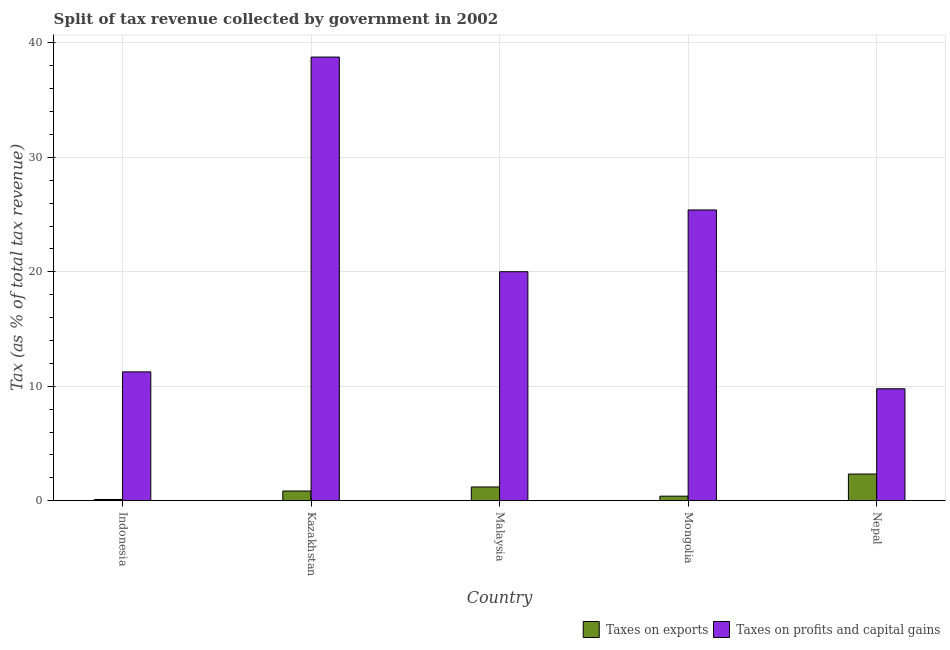Are the number of bars on each tick of the X-axis equal?
Your answer should be compact. Yes. How many bars are there on the 3rd tick from the right?
Your answer should be very brief. 2. What is the percentage of revenue obtained from taxes on exports in Nepal?
Provide a short and direct response. 2.33. Across all countries, what is the maximum percentage of revenue obtained from taxes on profits and capital gains?
Your answer should be very brief. 38.77. Across all countries, what is the minimum percentage of revenue obtained from taxes on profits and capital gains?
Offer a very short reply. 9.78. In which country was the percentage of revenue obtained from taxes on exports maximum?
Your answer should be compact. Nepal. In which country was the percentage of revenue obtained from taxes on profits and capital gains minimum?
Ensure brevity in your answer.  Nepal. What is the total percentage of revenue obtained from taxes on exports in the graph?
Your response must be concise. 4.89. What is the difference between the percentage of revenue obtained from taxes on exports in Indonesia and that in Malaysia?
Your answer should be very brief. -1.09. What is the difference between the percentage of revenue obtained from taxes on exports in Nepal and the percentage of revenue obtained from taxes on profits and capital gains in Mongolia?
Give a very brief answer. -23.07. What is the average percentage of revenue obtained from taxes on profits and capital gains per country?
Ensure brevity in your answer.  21.04. What is the difference between the percentage of revenue obtained from taxes on exports and percentage of revenue obtained from taxes on profits and capital gains in Malaysia?
Your answer should be very brief. -18.81. In how many countries, is the percentage of revenue obtained from taxes on profits and capital gains greater than 8 %?
Offer a terse response. 5. What is the ratio of the percentage of revenue obtained from taxes on exports in Malaysia to that in Mongolia?
Your answer should be compact. 3.02. What is the difference between the highest and the second highest percentage of revenue obtained from taxes on exports?
Your response must be concise. 1.13. What is the difference between the highest and the lowest percentage of revenue obtained from taxes on profits and capital gains?
Your response must be concise. 28.98. What does the 1st bar from the left in Indonesia represents?
Your answer should be compact. Taxes on exports. What does the 1st bar from the right in Kazakhstan represents?
Provide a succinct answer. Taxes on profits and capital gains. Are all the bars in the graph horizontal?
Your answer should be compact. No. How many countries are there in the graph?
Provide a succinct answer. 5. What is the difference between two consecutive major ticks on the Y-axis?
Give a very brief answer. 10. Does the graph contain grids?
Offer a terse response. Yes. Where does the legend appear in the graph?
Give a very brief answer. Bottom right. How are the legend labels stacked?
Make the answer very short. Horizontal. What is the title of the graph?
Provide a succinct answer. Split of tax revenue collected by government in 2002. Does "Researchers" appear as one of the legend labels in the graph?
Ensure brevity in your answer.  No. What is the label or title of the X-axis?
Your answer should be very brief. Country. What is the label or title of the Y-axis?
Offer a terse response. Tax (as % of total tax revenue). What is the Tax (as % of total tax revenue) of Taxes on exports in Indonesia?
Offer a terse response. 0.11. What is the Tax (as % of total tax revenue) of Taxes on profits and capital gains in Indonesia?
Your response must be concise. 11.26. What is the Tax (as % of total tax revenue) in Taxes on exports in Kazakhstan?
Offer a terse response. 0.85. What is the Tax (as % of total tax revenue) in Taxes on profits and capital gains in Kazakhstan?
Offer a very short reply. 38.77. What is the Tax (as % of total tax revenue) of Taxes on exports in Malaysia?
Make the answer very short. 1.2. What is the Tax (as % of total tax revenue) of Taxes on profits and capital gains in Malaysia?
Offer a very short reply. 20.01. What is the Tax (as % of total tax revenue) in Taxes on exports in Mongolia?
Offer a very short reply. 0.4. What is the Tax (as % of total tax revenue) of Taxes on profits and capital gains in Mongolia?
Offer a very short reply. 25.41. What is the Tax (as % of total tax revenue) of Taxes on exports in Nepal?
Keep it short and to the point. 2.33. What is the Tax (as % of total tax revenue) in Taxes on profits and capital gains in Nepal?
Offer a very short reply. 9.78. Across all countries, what is the maximum Tax (as % of total tax revenue) in Taxes on exports?
Provide a succinct answer. 2.33. Across all countries, what is the maximum Tax (as % of total tax revenue) in Taxes on profits and capital gains?
Your response must be concise. 38.77. Across all countries, what is the minimum Tax (as % of total tax revenue) of Taxes on exports?
Give a very brief answer. 0.11. Across all countries, what is the minimum Tax (as % of total tax revenue) in Taxes on profits and capital gains?
Your response must be concise. 9.78. What is the total Tax (as % of total tax revenue) in Taxes on exports in the graph?
Offer a terse response. 4.89. What is the total Tax (as % of total tax revenue) of Taxes on profits and capital gains in the graph?
Keep it short and to the point. 105.22. What is the difference between the Tax (as % of total tax revenue) in Taxes on exports in Indonesia and that in Kazakhstan?
Offer a very short reply. -0.74. What is the difference between the Tax (as % of total tax revenue) in Taxes on profits and capital gains in Indonesia and that in Kazakhstan?
Offer a very short reply. -27.51. What is the difference between the Tax (as % of total tax revenue) of Taxes on exports in Indonesia and that in Malaysia?
Your answer should be very brief. -1.09. What is the difference between the Tax (as % of total tax revenue) of Taxes on profits and capital gains in Indonesia and that in Malaysia?
Give a very brief answer. -8.75. What is the difference between the Tax (as % of total tax revenue) in Taxes on exports in Indonesia and that in Mongolia?
Give a very brief answer. -0.29. What is the difference between the Tax (as % of total tax revenue) of Taxes on profits and capital gains in Indonesia and that in Mongolia?
Keep it short and to the point. -14.15. What is the difference between the Tax (as % of total tax revenue) of Taxes on exports in Indonesia and that in Nepal?
Give a very brief answer. -2.22. What is the difference between the Tax (as % of total tax revenue) in Taxes on profits and capital gains in Indonesia and that in Nepal?
Provide a succinct answer. 1.48. What is the difference between the Tax (as % of total tax revenue) in Taxes on exports in Kazakhstan and that in Malaysia?
Give a very brief answer. -0.35. What is the difference between the Tax (as % of total tax revenue) in Taxes on profits and capital gains in Kazakhstan and that in Malaysia?
Ensure brevity in your answer.  18.76. What is the difference between the Tax (as % of total tax revenue) in Taxes on exports in Kazakhstan and that in Mongolia?
Offer a terse response. 0.45. What is the difference between the Tax (as % of total tax revenue) of Taxes on profits and capital gains in Kazakhstan and that in Mongolia?
Your response must be concise. 13.36. What is the difference between the Tax (as % of total tax revenue) of Taxes on exports in Kazakhstan and that in Nepal?
Your answer should be very brief. -1.48. What is the difference between the Tax (as % of total tax revenue) in Taxes on profits and capital gains in Kazakhstan and that in Nepal?
Your answer should be compact. 28.98. What is the difference between the Tax (as % of total tax revenue) of Taxes on exports in Malaysia and that in Mongolia?
Make the answer very short. 0.8. What is the difference between the Tax (as % of total tax revenue) in Taxes on profits and capital gains in Malaysia and that in Mongolia?
Offer a terse response. -5.4. What is the difference between the Tax (as % of total tax revenue) in Taxes on exports in Malaysia and that in Nepal?
Keep it short and to the point. -1.13. What is the difference between the Tax (as % of total tax revenue) of Taxes on profits and capital gains in Malaysia and that in Nepal?
Ensure brevity in your answer.  10.23. What is the difference between the Tax (as % of total tax revenue) of Taxes on exports in Mongolia and that in Nepal?
Provide a succinct answer. -1.93. What is the difference between the Tax (as % of total tax revenue) of Taxes on profits and capital gains in Mongolia and that in Nepal?
Keep it short and to the point. 15.62. What is the difference between the Tax (as % of total tax revenue) in Taxes on exports in Indonesia and the Tax (as % of total tax revenue) in Taxes on profits and capital gains in Kazakhstan?
Offer a very short reply. -38.66. What is the difference between the Tax (as % of total tax revenue) of Taxes on exports in Indonesia and the Tax (as % of total tax revenue) of Taxes on profits and capital gains in Malaysia?
Your response must be concise. -19.9. What is the difference between the Tax (as % of total tax revenue) in Taxes on exports in Indonesia and the Tax (as % of total tax revenue) in Taxes on profits and capital gains in Mongolia?
Offer a very short reply. -25.3. What is the difference between the Tax (as % of total tax revenue) in Taxes on exports in Indonesia and the Tax (as % of total tax revenue) in Taxes on profits and capital gains in Nepal?
Provide a succinct answer. -9.68. What is the difference between the Tax (as % of total tax revenue) of Taxes on exports in Kazakhstan and the Tax (as % of total tax revenue) of Taxes on profits and capital gains in Malaysia?
Your answer should be very brief. -19.16. What is the difference between the Tax (as % of total tax revenue) of Taxes on exports in Kazakhstan and the Tax (as % of total tax revenue) of Taxes on profits and capital gains in Mongolia?
Give a very brief answer. -24.56. What is the difference between the Tax (as % of total tax revenue) in Taxes on exports in Kazakhstan and the Tax (as % of total tax revenue) in Taxes on profits and capital gains in Nepal?
Offer a very short reply. -8.94. What is the difference between the Tax (as % of total tax revenue) in Taxes on exports in Malaysia and the Tax (as % of total tax revenue) in Taxes on profits and capital gains in Mongolia?
Ensure brevity in your answer.  -24.21. What is the difference between the Tax (as % of total tax revenue) in Taxes on exports in Malaysia and the Tax (as % of total tax revenue) in Taxes on profits and capital gains in Nepal?
Ensure brevity in your answer.  -8.58. What is the difference between the Tax (as % of total tax revenue) of Taxes on exports in Mongolia and the Tax (as % of total tax revenue) of Taxes on profits and capital gains in Nepal?
Provide a short and direct response. -9.39. What is the average Tax (as % of total tax revenue) in Taxes on exports per country?
Give a very brief answer. 0.98. What is the average Tax (as % of total tax revenue) of Taxes on profits and capital gains per country?
Your answer should be very brief. 21.04. What is the difference between the Tax (as % of total tax revenue) of Taxes on exports and Tax (as % of total tax revenue) of Taxes on profits and capital gains in Indonesia?
Your response must be concise. -11.15. What is the difference between the Tax (as % of total tax revenue) in Taxes on exports and Tax (as % of total tax revenue) in Taxes on profits and capital gains in Kazakhstan?
Your answer should be compact. -37.92. What is the difference between the Tax (as % of total tax revenue) of Taxes on exports and Tax (as % of total tax revenue) of Taxes on profits and capital gains in Malaysia?
Give a very brief answer. -18.81. What is the difference between the Tax (as % of total tax revenue) in Taxes on exports and Tax (as % of total tax revenue) in Taxes on profits and capital gains in Mongolia?
Your response must be concise. -25.01. What is the difference between the Tax (as % of total tax revenue) in Taxes on exports and Tax (as % of total tax revenue) in Taxes on profits and capital gains in Nepal?
Ensure brevity in your answer.  -7.45. What is the ratio of the Tax (as % of total tax revenue) in Taxes on exports in Indonesia to that in Kazakhstan?
Offer a very short reply. 0.13. What is the ratio of the Tax (as % of total tax revenue) in Taxes on profits and capital gains in Indonesia to that in Kazakhstan?
Offer a terse response. 0.29. What is the ratio of the Tax (as % of total tax revenue) of Taxes on exports in Indonesia to that in Malaysia?
Offer a terse response. 0.09. What is the ratio of the Tax (as % of total tax revenue) of Taxes on profits and capital gains in Indonesia to that in Malaysia?
Your answer should be compact. 0.56. What is the ratio of the Tax (as % of total tax revenue) in Taxes on exports in Indonesia to that in Mongolia?
Make the answer very short. 0.27. What is the ratio of the Tax (as % of total tax revenue) of Taxes on profits and capital gains in Indonesia to that in Mongolia?
Give a very brief answer. 0.44. What is the ratio of the Tax (as % of total tax revenue) of Taxes on exports in Indonesia to that in Nepal?
Provide a succinct answer. 0.05. What is the ratio of the Tax (as % of total tax revenue) of Taxes on profits and capital gains in Indonesia to that in Nepal?
Ensure brevity in your answer.  1.15. What is the ratio of the Tax (as % of total tax revenue) in Taxes on exports in Kazakhstan to that in Malaysia?
Your response must be concise. 0.71. What is the ratio of the Tax (as % of total tax revenue) in Taxes on profits and capital gains in Kazakhstan to that in Malaysia?
Keep it short and to the point. 1.94. What is the ratio of the Tax (as % of total tax revenue) of Taxes on exports in Kazakhstan to that in Mongolia?
Offer a very short reply. 2.13. What is the ratio of the Tax (as % of total tax revenue) in Taxes on profits and capital gains in Kazakhstan to that in Mongolia?
Offer a terse response. 1.53. What is the ratio of the Tax (as % of total tax revenue) in Taxes on exports in Kazakhstan to that in Nepal?
Your answer should be compact. 0.36. What is the ratio of the Tax (as % of total tax revenue) in Taxes on profits and capital gains in Kazakhstan to that in Nepal?
Ensure brevity in your answer.  3.96. What is the ratio of the Tax (as % of total tax revenue) in Taxes on exports in Malaysia to that in Mongolia?
Keep it short and to the point. 3.02. What is the ratio of the Tax (as % of total tax revenue) in Taxes on profits and capital gains in Malaysia to that in Mongolia?
Your response must be concise. 0.79. What is the ratio of the Tax (as % of total tax revenue) of Taxes on exports in Malaysia to that in Nepal?
Your answer should be compact. 0.52. What is the ratio of the Tax (as % of total tax revenue) of Taxes on profits and capital gains in Malaysia to that in Nepal?
Your response must be concise. 2.05. What is the ratio of the Tax (as % of total tax revenue) in Taxes on exports in Mongolia to that in Nepal?
Provide a short and direct response. 0.17. What is the ratio of the Tax (as % of total tax revenue) in Taxes on profits and capital gains in Mongolia to that in Nepal?
Offer a very short reply. 2.6. What is the difference between the highest and the second highest Tax (as % of total tax revenue) in Taxes on exports?
Offer a very short reply. 1.13. What is the difference between the highest and the second highest Tax (as % of total tax revenue) of Taxes on profits and capital gains?
Make the answer very short. 13.36. What is the difference between the highest and the lowest Tax (as % of total tax revenue) of Taxes on exports?
Your answer should be compact. 2.22. What is the difference between the highest and the lowest Tax (as % of total tax revenue) in Taxes on profits and capital gains?
Your answer should be compact. 28.98. 